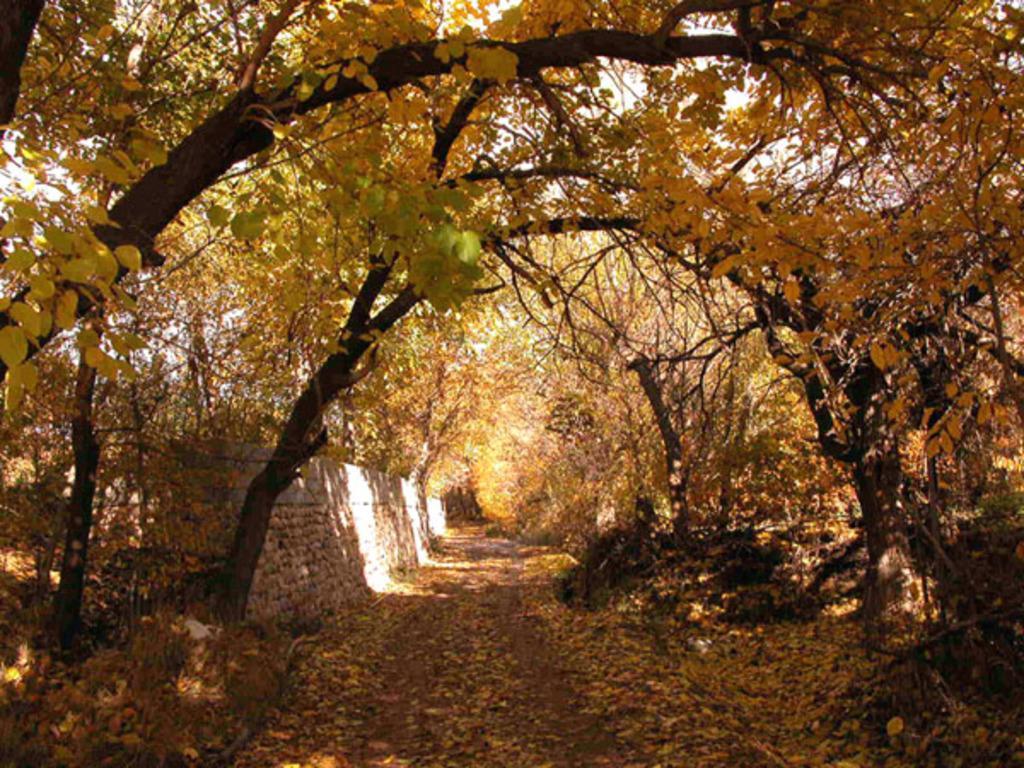Could you give a brief overview of what you see in this image? In this picture I can see trees and a wall on the left side and I can see few leaves on the ground and I can see sky. 